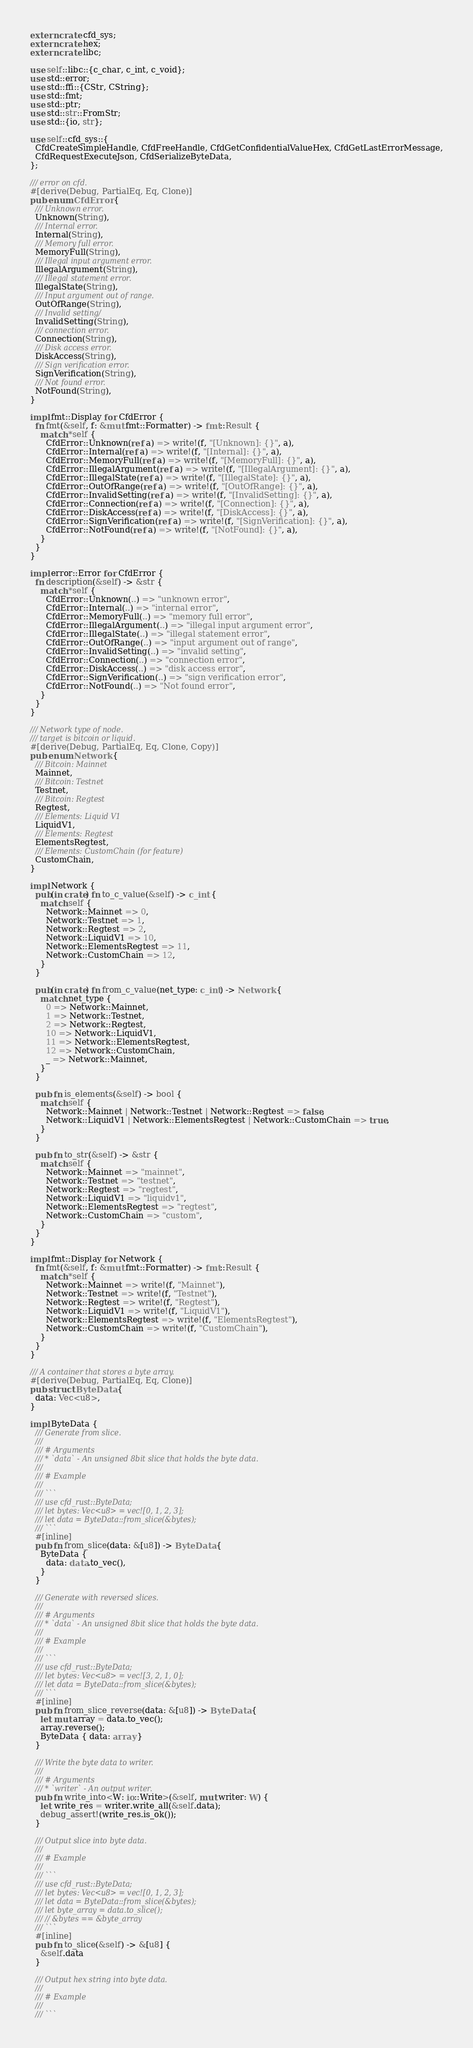Convert code to text. <code><loc_0><loc_0><loc_500><loc_500><_Rust_>extern crate cfd_sys;
extern crate hex;
extern crate libc;

use self::libc::{c_char, c_int, c_void};
use std::error;
use std::ffi::{CStr, CString};
use std::fmt;
use std::ptr;
use std::str::FromStr;
use std::{io, str};

use self::cfd_sys::{
  CfdCreateSimpleHandle, CfdFreeHandle, CfdGetConfidentialValueHex, CfdGetLastErrorMessage,
  CfdRequestExecuteJson, CfdSerializeByteData,
};

/// error on cfd.
#[derive(Debug, PartialEq, Eq, Clone)]
pub enum CfdError {
  /// Unknown error.
  Unknown(String),
  /// Internal error.
  Internal(String),
  /// Memory full error.
  MemoryFull(String),
  /// Illegal input argument error.
  IllegalArgument(String),
  /// Illegal statement error.
  IllegalState(String),
  /// Input argument out of range.
  OutOfRange(String),
  /// Invalid setting/
  InvalidSetting(String),
  /// connection error.
  Connection(String),
  /// Disk access error.
  DiskAccess(String),
  /// Sign verification error.
  SignVerification(String),
  /// Not found error.
  NotFound(String),
}

impl fmt::Display for CfdError {
  fn fmt(&self, f: &mut fmt::Formatter) -> fmt::Result {
    match *self {
      CfdError::Unknown(ref a) => write!(f, "[Unknown]: {}", a),
      CfdError::Internal(ref a) => write!(f, "[Internal]: {}", a),
      CfdError::MemoryFull(ref a) => write!(f, "[MemoryFull]: {}", a),
      CfdError::IllegalArgument(ref a) => write!(f, "[IllegalArgument]: {}", a),
      CfdError::IllegalState(ref a) => write!(f, "[IllegalState]: {}", a),
      CfdError::OutOfRange(ref a) => write!(f, "[OutOfRange]: {}", a),
      CfdError::InvalidSetting(ref a) => write!(f, "[InvalidSetting]: {}", a),
      CfdError::Connection(ref a) => write!(f, "[Connection]: {}", a),
      CfdError::DiskAccess(ref a) => write!(f, "[DiskAccess]: {}", a),
      CfdError::SignVerification(ref a) => write!(f, "[SignVerification]: {}", a),
      CfdError::NotFound(ref a) => write!(f, "[NotFound]: {}", a),
    }
  }
}

impl error::Error for CfdError {
  fn description(&self) -> &str {
    match *self {
      CfdError::Unknown(..) => "unknown error",
      CfdError::Internal(..) => "internal error",
      CfdError::MemoryFull(..) => "memory full error",
      CfdError::IllegalArgument(..) => "illegal input argument error",
      CfdError::IllegalState(..) => "illegal statement error",
      CfdError::OutOfRange(..) => "input argument out of range",
      CfdError::InvalidSetting(..) => "invalid setting",
      CfdError::Connection(..) => "connection error",
      CfdError::DiskAccess(..) => "disk access error",
      CfdError::SignVerification(..) => "sign verification error",
      CfdError::NotFound(..) => "Not found error",
    }
  }
}

/// Network type of node.
/// target is bitcoin or liquid.
#[derive(Debug, PartialEq, Eq, Clone, Copy)]
pub enum Network {
  /// Bitcoin: Mainnet
  Mainnet,
  /// Bitcoin: Testnet
  Testnet,
  /// Bitcoin: Regtest
  Regtest,
  /// Elements: Liquid V1
  LiquidV1,
  /// Elements: Regtest
  ElementsRegtest,
  /// Elements: CustomChain (for feature)
  CustomChain,
}

impl Network {
  pub(in crate) fn to_c_value(&self) -> c_int {
    match self {
      Network::Mainnet => 0,
      Network::Testnet => 1,
      Network::Regtest => 2,
      Network::LiquidV1 => 10,
      Network::ElementsRegtest => 11,
      Network::CustomChain => 12,
    }
  }

  pub(in crate) fn from_c_value(net_type: c_int) -> Network {
    match net_type {
      0 => Network::Mainnet,
      1 => Network::Testnet,
      2 => Network::Regtest,
      10 => Network::LiquidV1,
      11 => Network::ElementsRegtest,
      12 => Network::CustomChain,
      _ => Network::Mainnet,
    }
  }

  pub fn is_elements(&self) -> bool {
    match self {
      Network::Mainnet | Network::Testnet | Network::Regtest => false,
      Network::LiquidV1 | Network::ElementsRegtest | Network::CustomChain => true,
    }
  }

  pub fn to_str(&self) -> &str {
    match self {
      Network::Mainnet => "mainnet",
      Network::Testnet => "testnet",
      Network::Regtest => "regtest",
      Network::LiquidV1 => "liquidv1",
      Network::ElementsRegtest => "regtest",
      Network::CustomChain => "custom",
    }
  }
}

impl fmt::Display for Network {
  fn fmt(&self, f: &mut fmt::Formatter) -> fmt::Result {
    match *self {
      Network::Mainnet => write!(f, "Mainnet"),
      Network::Testnet => write!(f, "Testnet"),
      Network::Regtest => write!(f, "Regtest"),
      Network::LiquidV1 => write!(f, "LiquidV1"),
      Network::ElementsRegtest => write!(f, "ElementsRegtest"),
      Network::CustomChain => write!(f, "CustomChain"),
    }
  }
}

/// A container that stores a byte array.
#[derive(Debug, PartialEq, Eq, Clone)]
pub struct ByteData {
  data: Vec<u8>,
}

impl ByteData {
  /// Generate from slice.
  ///
  /// # Arguments
  /// * `data` - An unsigned 8bit slice that holds the byte data.
  ///
  /// # Example
  ///
  /// ```
  /// use cfd_rust::ByteData;
  /// let bytes: Vec<u8> = vec![0, 1, 2, 3];
  /// let data = ByteData::from_slice(&bytes);
  /// ```
  #[inline]
  pub fn from_slice(data: &[u8]) -> ByteData {
    ByteData {
      data: data.to_vec(),
    }
  }

  /// Generate with reversed slices.
  ///
  /// # Arguments
  /// * `data` - An unsigned 8bit slice that holds the byte data.
  ///
  /// # Example
  ///
  /// ```
  /// use cfd_rust::ByteData;
  /// let bytes: Vec<u8> = vec![3, 2, 1, 0];
  /// let data = ByteData::from_slice(&bytes);
  /// ```
  #[inline]
  pub fn from_slice_reverse(data: &[u8]) -> ByteData {
    let mut array = data.to_vec();
    array.reverse();
    ByteData { data: array }
  }

  /// Write the byte data to writer.
  ///
  /// # Arguments
  /// * `writer` - An output writer.
  pub fn write_into<W: io::Write>(&self, mut writer: W) {
    let write_res = writer.write_all(&self.data);
    debug_assert!(write_res.is_ok());
  }

  /// Output slice into byte data.
  ///
  /// # Example
  ///
  /// ```
  /// use cfd_rust::ByteData;
  /// let bytes: Vec<u8> = vec![0, 1, 2, 3];
  /// let data = ByteData::from_slice(&bytes);
  /// let byte_array = data.to_slice();
  /// // &bytes == &byte_array
  /// ```
  #[inline]
  pub fn to_slice(&self) -> &[u8] {
    &self.data
  }

  /// Output hex string into byte data.
  ///
  /// # Example
  ///
  /// ```</code> 